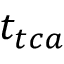<formula> <loc_0><loc_0><loc_500><loc_500>t _ { t c a }</formula> 